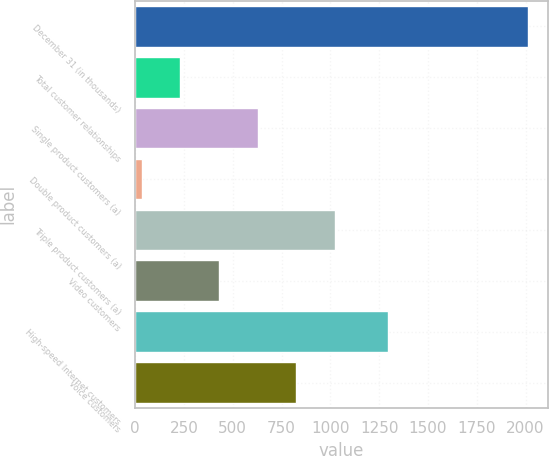Convert chart to OTSL. <chart><loc_0><loc_0><loc_500><loc_500><bar_chart><fcel>December 31 (in thousands)<fcel>Total customer relationships<fcel>Single product customers (a)<fcel>Double product customers (a)<fcel>Triple product customers (a)<fcel>Video customers<fcel>High-speed Internet customers<fcel>Voice customers<nl><fcel>2013<fcel>231.9<fcel>627.7<fcel>34<fcel>1023.5<fcel>429.8<fcel>1296<fcel>825.6<nl></chart> 